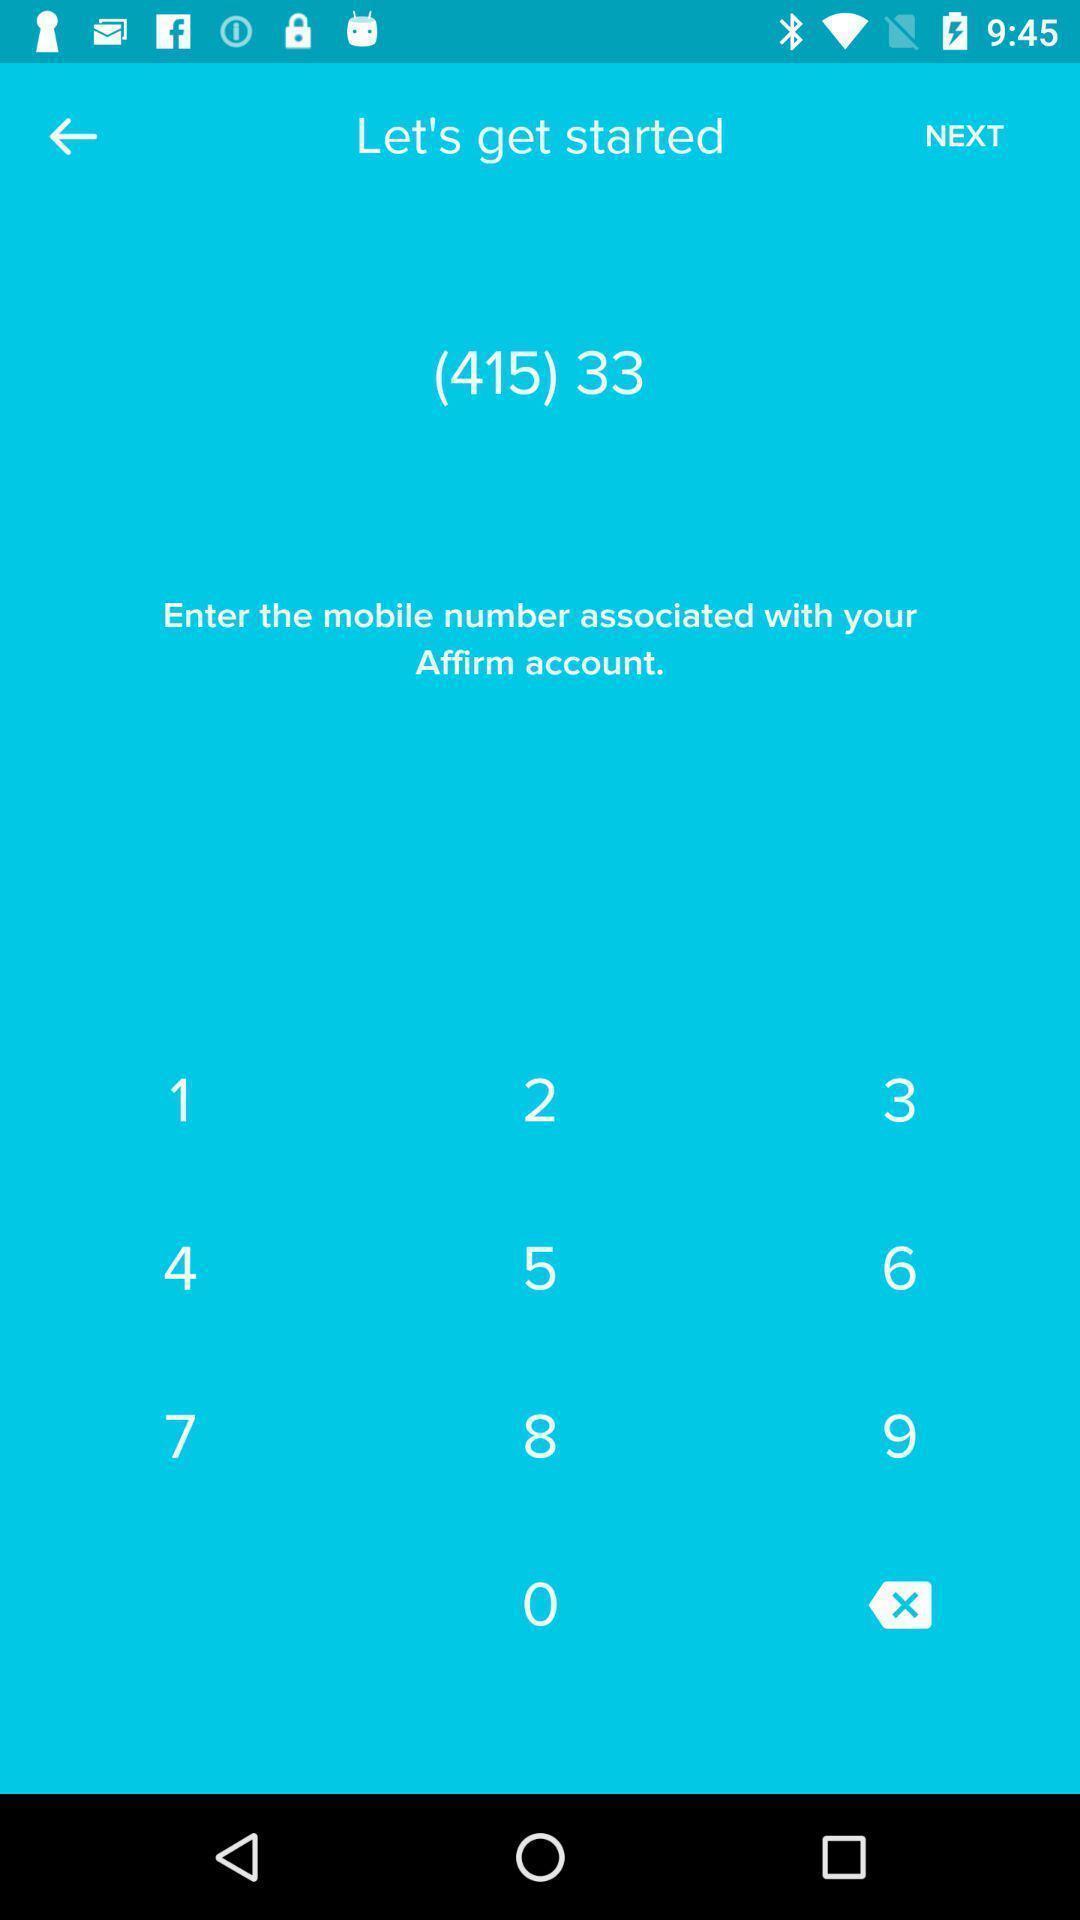Please provide a description for this image. Screen page showing keypad. 